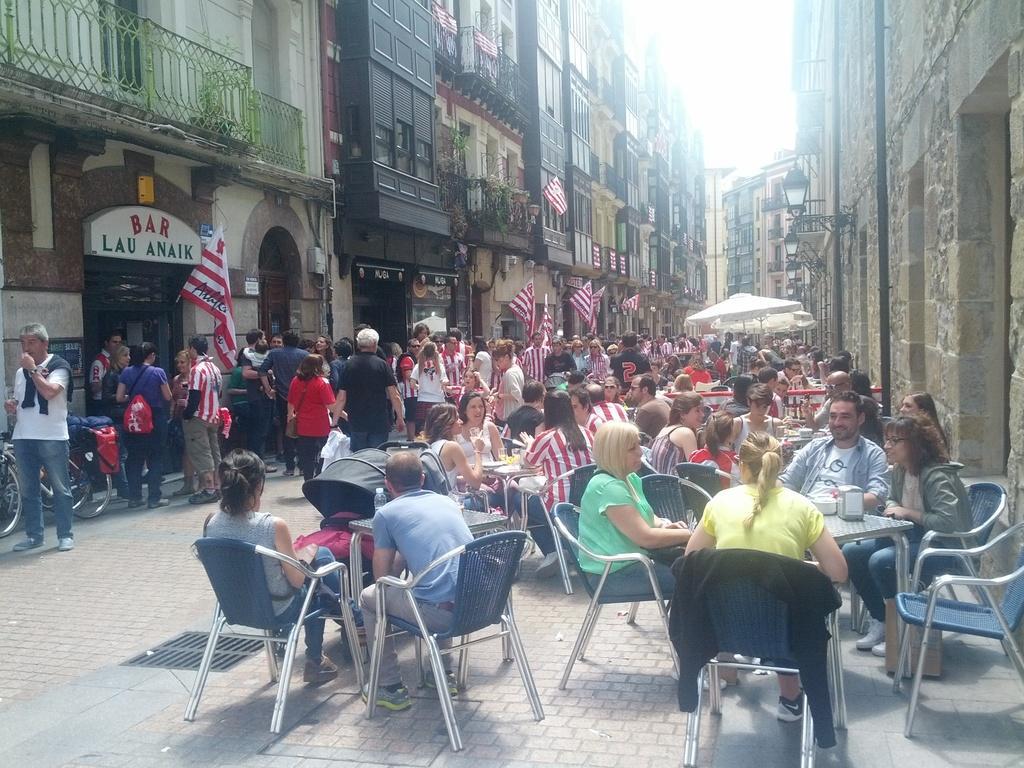Describe this image in one or two sentences. As we can see in the image, there are lots of people. Some of them are walking on road and few of them are sittings and there are flags, buildings and plants. 